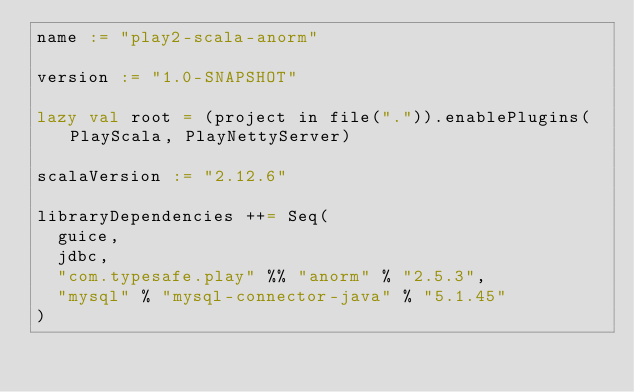Convert code to text. <code><loc_0><loc_0><loc_500><loc_500><_Scala_>name := "play2-scala-anorm"

version := "1.0-SNAPSHOT"

lazy val root = (project in file(".")).enablePlugins(PlayScala, PlayNettyServer)

scalaVersion := "2.12.6"

libraryDependencies ++= Seq(
  guice,
  jdbc,
  "com.typesafe.play" %% "anorm" % "2.5.3",
  "mysql" % "mysql-connector-java" % "5.1.45"
)
</code> 